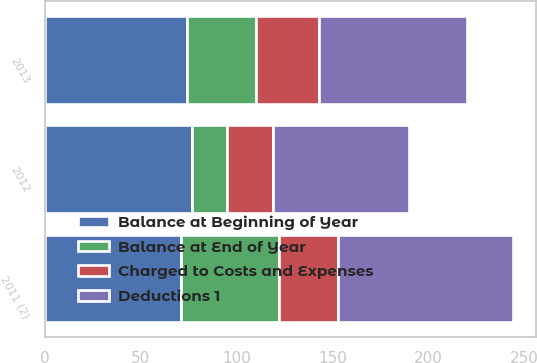<chart> <loc_0><loc_0><loc_500><loc_500><stacked_bar_chart><ecel><fcel>2013<fcel>2012<fcel>2011 (2)<nl><fcel>Deductions 1<fcel>77<fcel>71<fcel>91<nl><fcel>Charged to Costs and Expenses<fcel>33<fcel>24<fcel>31<nl><fcel>Balance at End of Year<fcel>36<fcel>18<fcel>51<nl><fcel>Balance at Beginning of Year<fcel>74<fcel>77<fcel>71<nl></chart> 